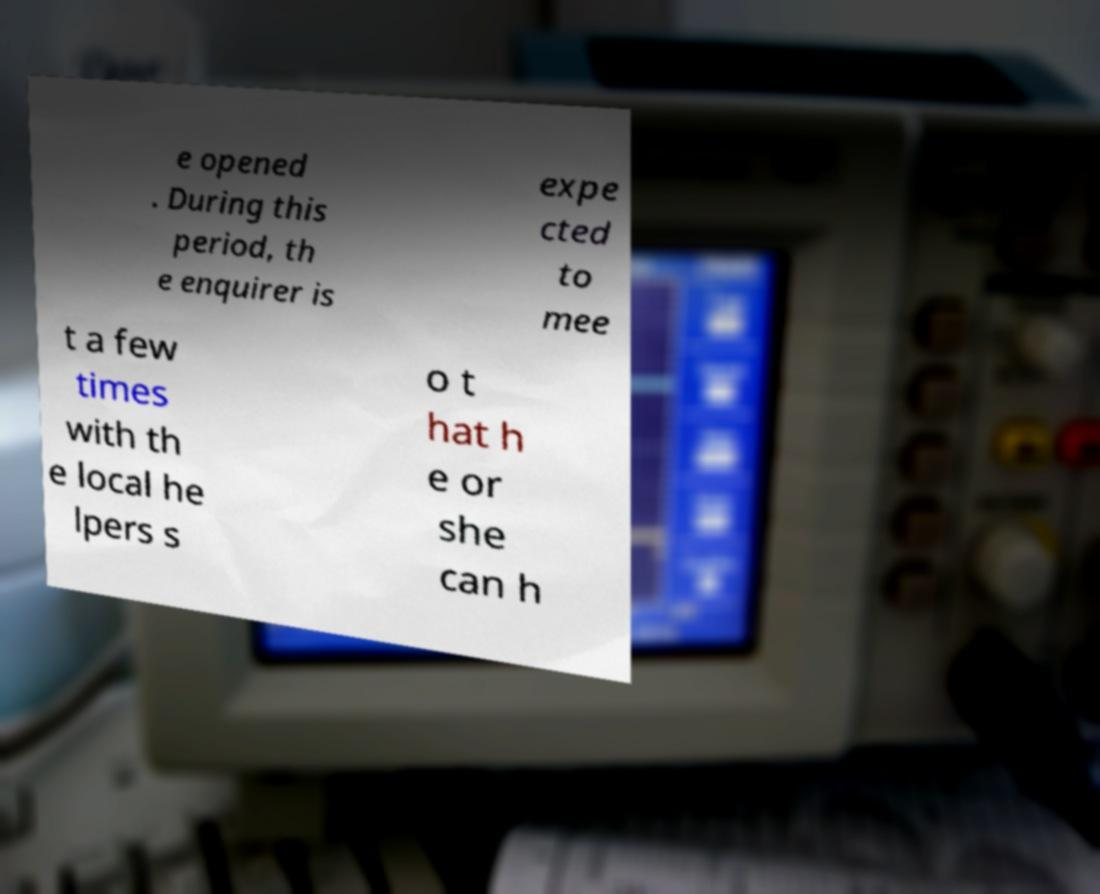What messages or text are displayed in this image? I need them in a readable, typed format. e opened . During this period, th e enquirer is expe cted to mee t a few times with th e local he lpers s o t hat h e or she can h 